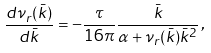<formula> <loc_0><loc_0><loc_500><loc_500>\frac { d \nu _ { r } ( \bar { k } ) } { d \bar { k } } = - \frac { \tau } { 1 6 \pi } \frac { \bar { k } } { \alpha + \nu _ { r } ( \bar { k } ) \bar { k } ^ { 2 } } \, ,</formula> 